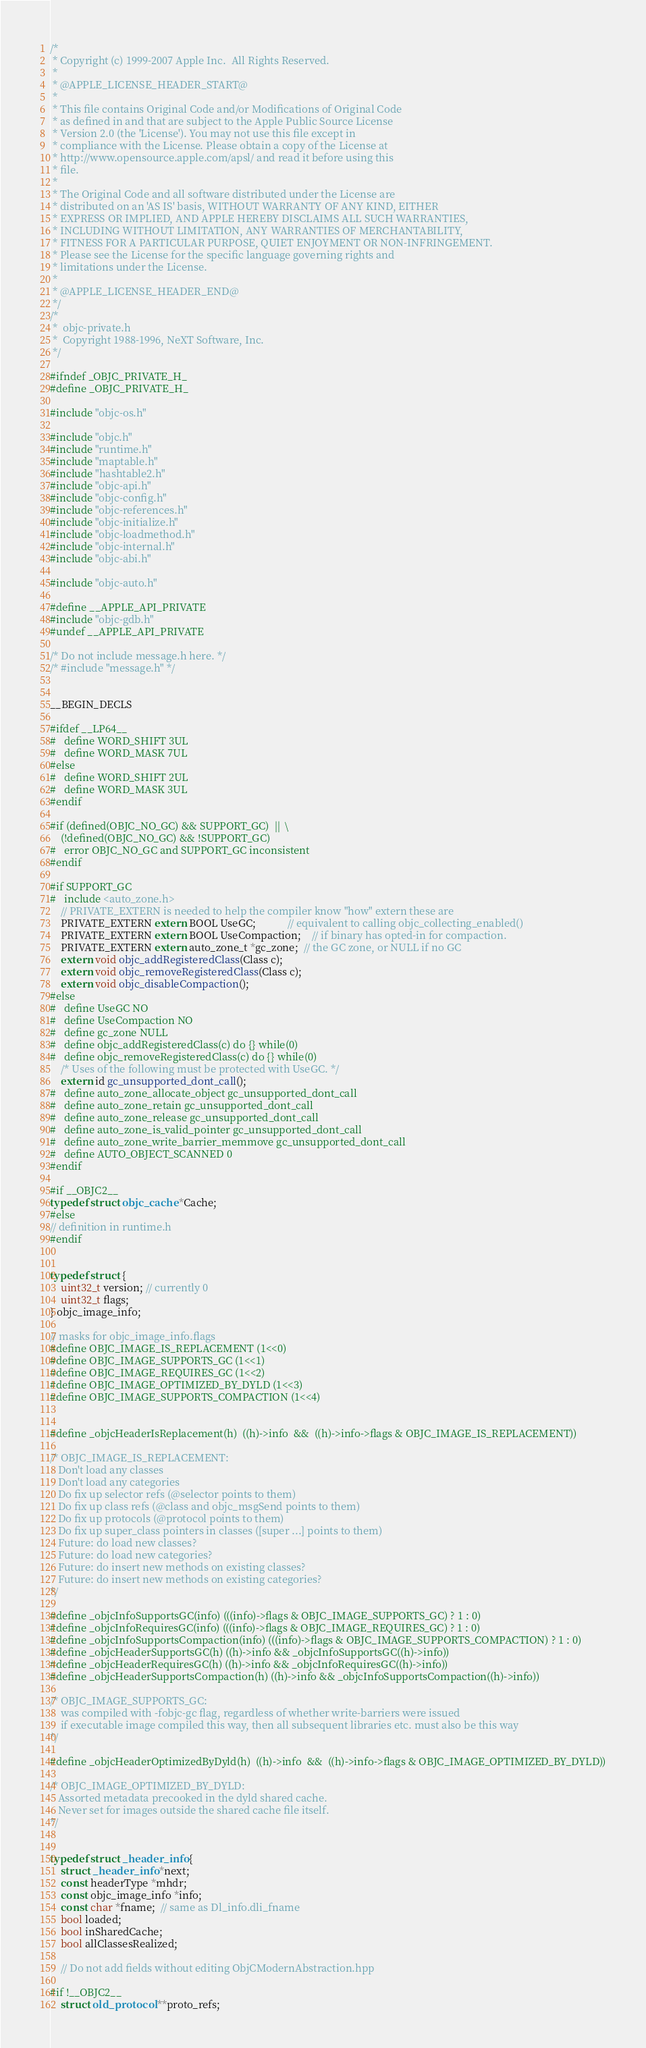<code> <loc_0><loc_0><loc_500><loc_500><_C_>/*
 * Copyright (c) 1999-2007 Apple Inc.  All Rights Reserved.
 * 
 * @APPLE_LICENSE_HEADER_START@
 * 
 * This file contains Original Code and/or Modifications of Original Code
 * as defined in and that are subject to the Apple Public Source License
 * Version 2.0 (the 'License'). You may not use this file except in
 * compliance with the License. Please obtain a copy of the License at
 * http://www.opensource.apple.com/apsl/ and read it before using this
 * file.
 * 
 * The Original Code and all software distributed under the License are
 * distributed on an 'AS IS' basis, WITHOUT WARRANTY OF ANY KIND, EITHER
 * EXPRESS OR IMPLIED, AND APPLE HEREBY DISCLAIMS ALL SUCH WARRANTIES,
 * INCLUDING WITHOUT LIMITATION, ANY WARRANTIES OF MERCHANTABILITY,
 * FITNESS FOR A PARTICULAR PURPOSE, QUIET ENJOYMENT OR NON-INFRINGEMENT.
 * Please see the License for the specific language governing rights and
 * limitations under the License.
 * 
 * @APPLE_LICENSE_HEADER_END@
 */
/*
 *	objc-private.h
 *	Copyright 1988-1996, NeXT Software, Inc.
 */

#ifndef _OBJC_PRIVATE_H_
#define _OBJC_PRIVATE_H_

#include "objc-os.h"

#include "objc.h"
#include "runtime.h"
#include "maptable.h"
#include "hashtable2.h"
#include "objc-api.h"
#include "objc-config.h"
#include "objc-references.h"
#include "objc-initialize.h"
#include "objc-loadmethod.h"
#include "objc-internal.h"
#include "objc-abi.h"

#include "objc-auto.h"

#define __APPLE_API_PRIVATE
#include "objc-gdb.h"
#undef __APPLE_API_PRIVATE

/* Do not include message.h here. */
/* #include "message.h" */


__BEGIN_DECLS

#ifdef __LP64__
#   define WORD_SHIFT 3UL
#   define WORD_MASK 7UL
#else
#   define WORD_SHIFT 2UL
#   define WORD_MASK 3UL
#endif

#if (defined(OBJC_NO_GC) && SUPPORT_GC)  ||  \
    (!defined(OBJC_NO_GC) && !SUPPORT_GC)
#   error OBJC_NO_GC and SUPPORT_GC inconsistent
#endif

#if SUPPORT_GC
#   include <auto_zone.h>
	// PRIVATE_EXTERN is needed to help the compiler know "how" extern these are
    PRIVATE_EXTERN extern BOOL UseGC;            // equivalent to calling objc_collecting_enabled()
    PRIVATE_EXTERN extern BOOL UseCompaction;    // if binary has opted-in for compaction.
    PRIVATE_EXTERN extern auto_zone_t *gc_zone;  // the GC zone, or NULL if no GC
    extern void objc_addRegisteredClass(Class c);
    extern void objc_removeRegisteredClass(Class c);
    extern void objc_disableCompaction();
#else
#   define UseGC NO
#   define UseCompaction NO
#   define gc_zone NULL
#   define objc_addRegisteredClass(c) do {} while(0)
#   define objc_removeRegisteredClass(c) do {} while(0)
    /* Uses of the following must be protected with UseGC. */
    extern id gc_unsupported_dont_call();
#   define auto_zone_allocate_object gc_unsupported_dont_call
#   define auto_zone_retain gc_unsupported_dont_call
#   define auto_zone_release gc_unsupported_dont_call
#   define auto_zone_is_valid_pointer gc_unsupported_dont_call
#   define auto_zone_write_barrier_memmove gc_unsupported_dont_call
#   define AUTO_OBJECT_SCANNED 0
#endif

#if __OBJC2__
typedef struct objc_cache *Cache;
#else 
// definition in runtime.h
#endif


typedef struct {
    uint32_t version; // currently 0
    uint32_t flags;
} objc_image_info;

// masks for objc_image_info.flags
#define OBJC_IMAGE_IS_REPLACEMENT (1<<0)
#define OBJC_IMAGE_SUPPORTS_GC (1<<1)
#define OBJC_IMAGE_REQUIRES_GC (1<<2)
#define OBJC_IMAGE_OPTIMIZED_BY_DYLD (1<<3)
#define OBJC_IMAGE_SUPPORTS_COMPACTION (1<<4)


#define _objcHeaderIsReplacement(h)  ((h)->info  &&  ((h)->info->flags & OBJC_IMAGE_IS_REPLACEMENT))

/* OBJC_IMAGE_IS_REPLACEMENT:
   Don't load any classes
   Don't load any categories
   Do fix up selector refs (@selector points to them)
   Do fix up class refs (@class and objc_msgSend points to them)
   Do fix up protocols (@protocol points to them)
   Do fix up super_class pointers in classes ([super ...] points to them)
   Future: do load new classes?
   Future: do load new categories?
   Future: do insert new methods on existing classes?
   Future: do insert new methods on existing categories?
*/

#define _objcInfoSupportsGC(info) (((info)->flags & OBJC_IMAGE_SUPPORTS_GC) ? 1 : 0)
#define _objcInfoRequiresGC(info) (((info)->flags & OBJC_IMAGE_REQUIRES_GC) ? 1 : 0)
#define _objcInfoSupportsCompaction(info) (((info)->flags & OBJC_IMAGE_SUPPORTS_COMPACTION) ? 1 : 0)
#define _objcHeaderSupportsGC(h) ((h)->info && _objcInfoSupportsGC((h)->info))
#define _objcHeaderRequiresGC(h) ((h)->info && _objcInfoRequiresGC((h)->info))
#define _objcHeaderSupportsCompaction(h) ((h)->info && _objcInfoSupportsCompaction((h)->info))

/* OBJC_IMAGE_SUPPORTS_GC:
    was compiled with -fobjc-gc flag, regardless of whether write-barriers were issued
    if executable image compiled this way, then all subsequent libraries etc. must also be this way
*/

#define _objcHeaderOptimizedByDyld(h)  ((h)->info  &&  ((h)->info->flags & OBJC_IMAGE_OPTIMIZED_BY_DYLD))

/* OBJC_IMAGE_OPTIMIZED_BY_DYLD:
   Assorted metadata precooked in the dyld shared cache.
   Never set for images outside the shared cache file itself.
*/
   

typedef struct _header_info {
    struct _header_info *next;
    const headerType *mhdr;
    const objc_image_info *info;
    const char *fname;  // same as Dl_info.dli_fname
    bool loaded;
    bool inSharedCache;
    bool allClassesRealized;

    // Do not add fields without editing ObjCModernAbstraction.hpp

#if !__OBJC2__
    struct old_protocol **proto_refs;</code> 